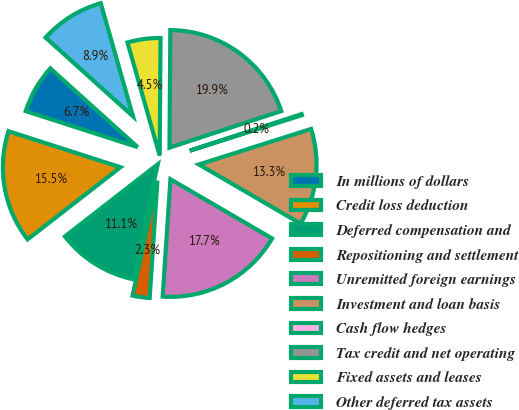Convert chart. <chart><loc_0><loc_0><loc_500><loc_500><pie_chart><fcel>In millions of dollars<fcel>Credit loss deduction<fcel>Deferred compensation and<fcel>Repositioning and settlement<fcel>Unremitted foreign earnings<fcel>Investment and loan basis<fcel>Cash flow hedges<fcel>Tax credit and net operating<fcel>Fixed assets and leases<fcel>Other deferred tax assets<nl><fcel>6.72%<fcel>15.47%<fcel>11.09%<fcel>2.34%<fcel>17.66%<fcel>13.28%<fcel>0.15%<fcel>19.85%<fcel>4.53%<fcel>8.91%<nl></chart> 